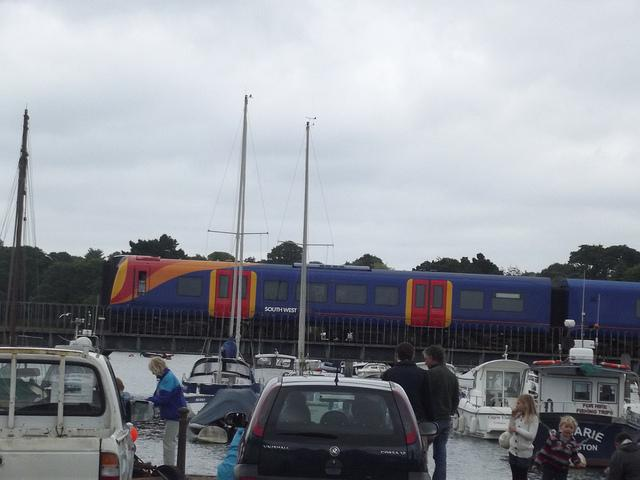Which vehicle holds the most people? Please explain your reasoning. train. The vehicle is the train. 